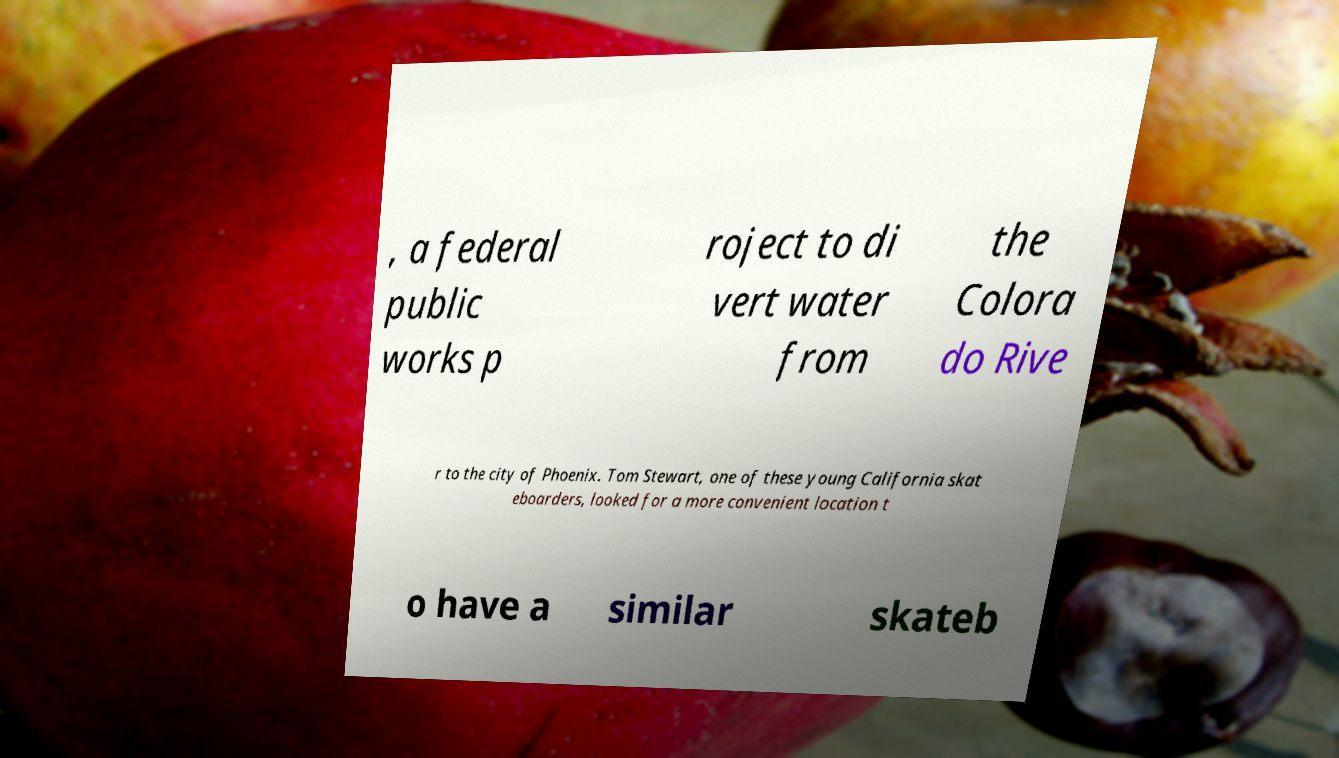Please identify and transcribe the text found in this image. , a federal public works p roject to di vert water from the Colora do Rive r to the city of Phoenix. Tom Stewart, one of these young California skat eboarders, looked for a more convenient location t o have a similar skateb 